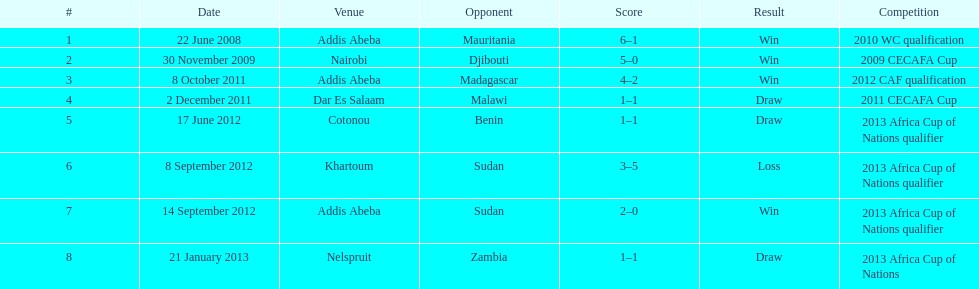What were the scores for each victorious game? 6-1, 5-0, 4-2, 2-0. 